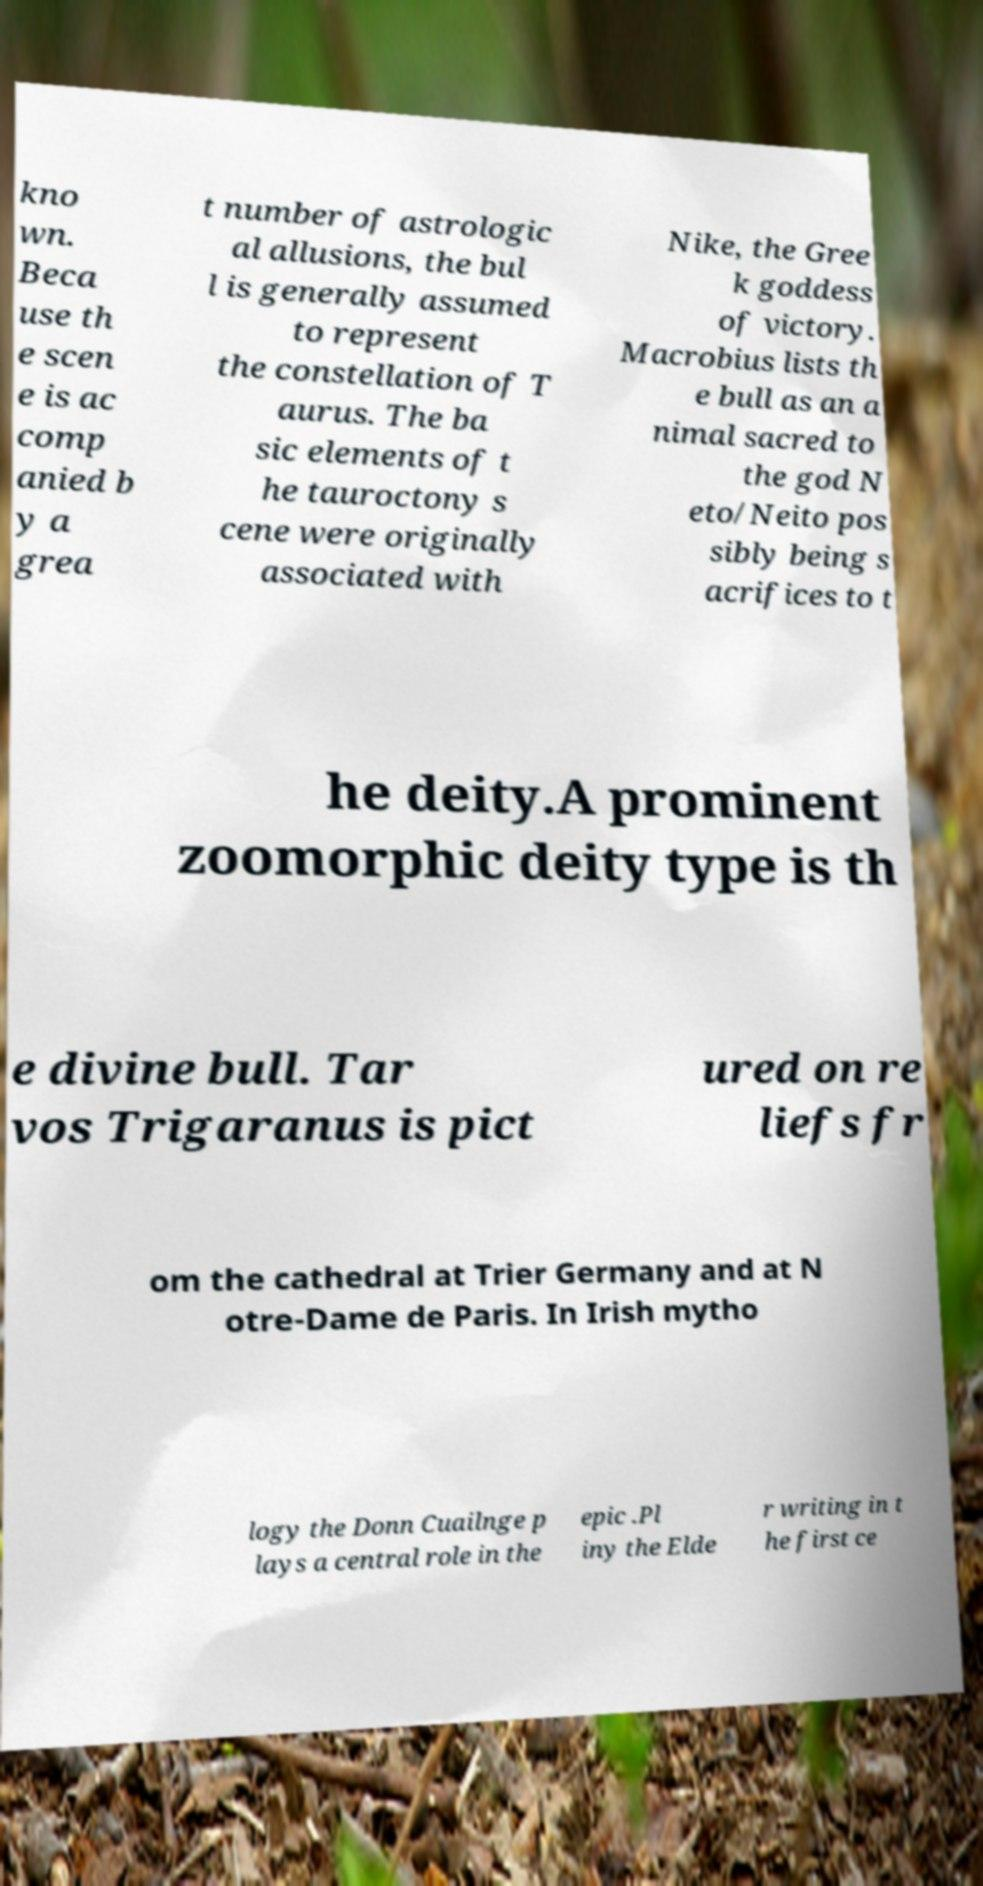For documentation purposes, I need the text within this image transcribed. Could you provide that? kno wn. Beca use th e scen e is ac comp anied b y a grea t number of astrologic al allusions, the bul l is generally assumed to represent the constellation of T aurus. The ba sic elements of t he tauroctony s cene were originally associated with Nike, the Gree k goddess of victory. Macrobius lists th e bull as an a nimal sacred to the god N eto/Neito pos sibly being s acrifices to t he deity.A prominent zoomorphic deity type is th e divine bull. Tar vos Trigaranus is pict ured on re liefs fr om the cathedral at Trier Germany and at N otre-Dame de Paris. In Irish mytho logy the Donn Cuailnge p lays a central role in the epic .Pl iny the Elde r writing in t he first ce 